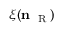Convert formula to latex. <formula><loc_0><loc_0><loc_500><loc_500>\xi ( n _ { R } )</formula> 